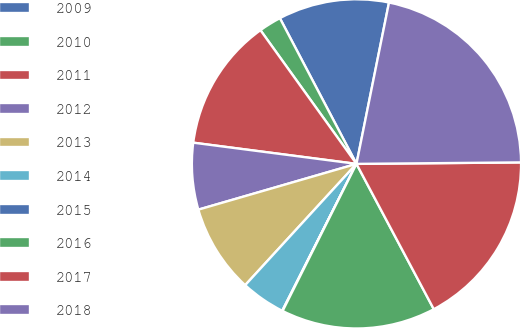Convert chart to OTSL. <chart><loc_0><loc_0><loc_500><loc_500><pie_chart><fcel>2009<fcel>2010<fcel>2011<fcel>2012<fcel>2013<fcel>2014<fcel>2015<fcel>2016<fcel>2017<fcel>2018<nl><fcel>10.87%<fcel>2.21%<fcel>13.03%<fcel>6.54%<fcel>8.7%<fcel>4.37%<fcel>0.04%<fcel>15.19%<fcel>17.36%<fcel>21.69%<nl></chart> 